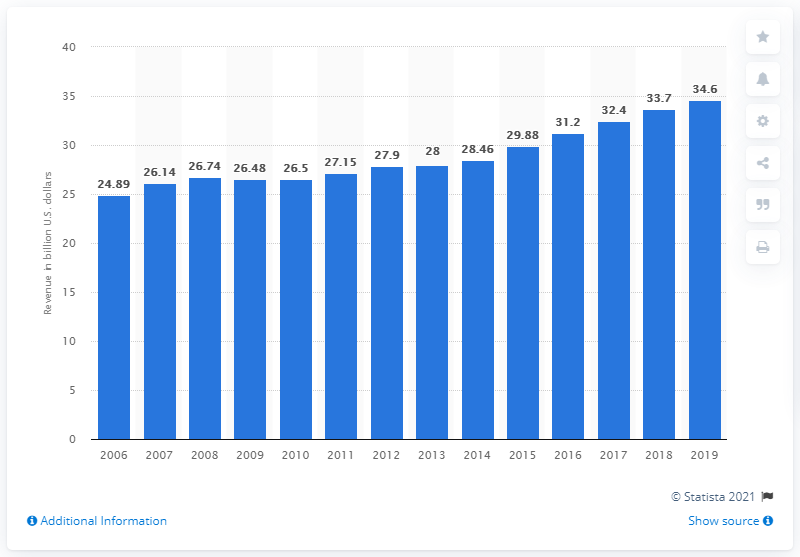Point out several critical features in this image. The total income of the Indian gaming industry in the United States in the previous year was 33.7 billion dollars. The Indian gaming industry in the U.S. generated an income of 34.6 billion dollars in 2020. 